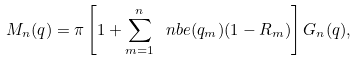Convert formula to latex. <formula><loc_0><loc_0><loc_500><loc_500>M _ { n } ( q ) = \pi \left [ 1 + \sum _ { m = 1 } ^ { n } \ n b e ( q _ { m } ) ( 1 - R _ { m } ) \right ] G _ { n } ( q ) ,</formula> 